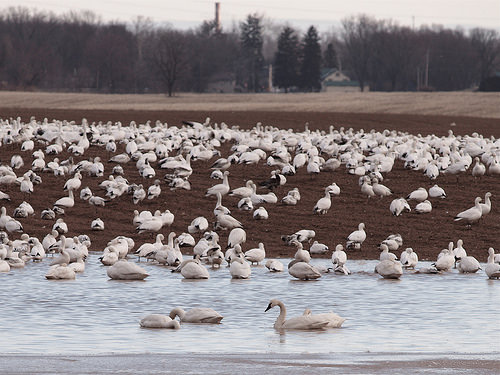<image>
Is there a barn behind the shore? Yes. From this viewpoint, the barn is positioned behind the shore, with the shore partially or fully occluding the barn. Is the bird above the ground? Yes. The bird is positioned above the ground in the vertical space, higher up in the scene. 